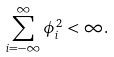<formula> <loc_0><loc_0><loc_500><loc_500>\sum _ { i = - \infty } ^ { \infty } \phi _ { i } ^ { 2 } < \infty .</formula> 